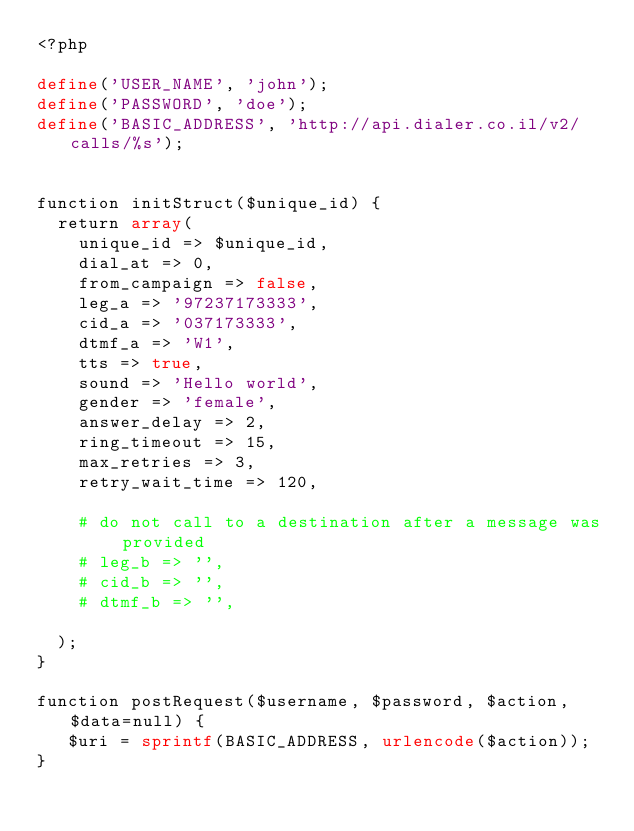<code> <loc_0><loc_0><loc_500><loc_500><_PHP_><?php

define('USER_NAME', 'john');
define('PASSWORD', 'doe');
define('BASIC_ADDRESS', 'http://api.dialer.co.il/v2/calls/%s');


function initStruct($unique_id) {
  return array(
    unique_id => $unique_id,
    dial_at => 0,
    from_campaign => false,
    leg_a => '97237173333',
    cid_a => '037173333',
    dtmf_a => 'W1',
    tts => true,
    sound => 'Hello world',
    gender => 'female',
    answer_delay => 2,
    ring_timeout => 15,
    max_retries => 3,
    retry_wait_time => 120,

    # do not call to a destination after a message was provided
    # leg_b => '',
    # cid_b => '',
    # dtmf_b => '',

  );
}

function postRequest($username, $password, $action, $data=null) {
   $uri = sprintf(BASIC_ADDRESS, urlencode($action));
}

</code> 